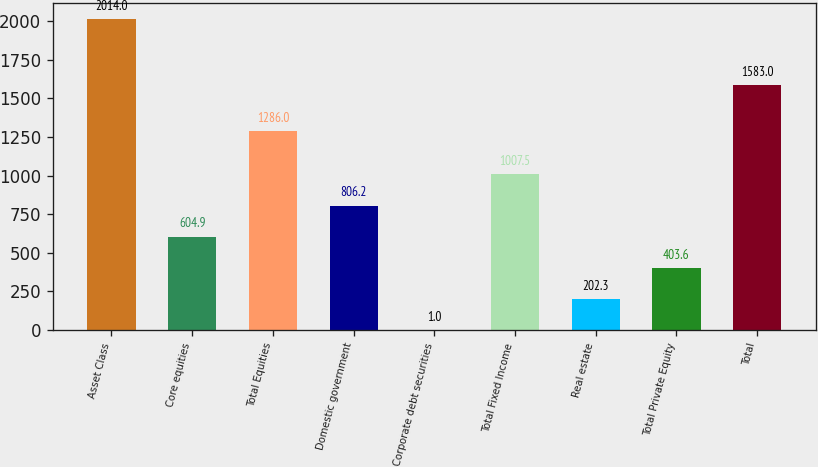<chart> <loc_0><loc_0><loc_500><loc_500><bar_chart><fcel>Asset Class<fcel>Core equities<fcel>Total Equities<fcel>Domestic government<fcel>Corporate debt securities<fcel>Total Fixed Income<fcel>Real estate<fcel>Total Private Equity<fcel>Total<nl><fcel>2014<fcel>604.9<fcel>1286<fcel>806.2<fcel>1<fcel>1007.5<fcel>202.3<fcel>403.6<fcel>1583<nl></chart> 